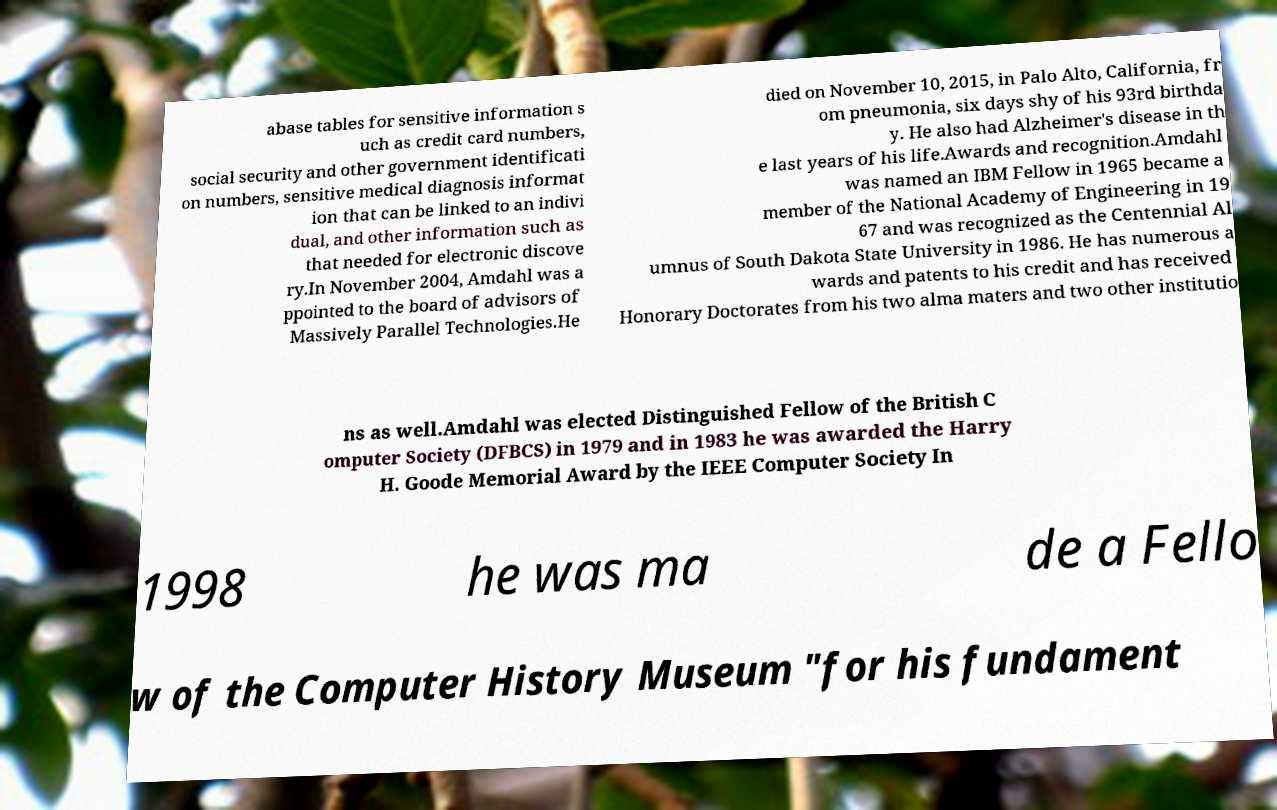Could you assist in decoding the text presented in this image and type it out clearly? abase tables for sensitive information s uch as credit card numbers, social security and other government identificati on numbers, sensitive medical diagnosis informat ion that can be linked to an indivi dual, and other information such as that needed for electronic discove ry.In November 2004, Amdahl was a ppointed to the board of advisors of Massively Parallel Technologies.He died on November 10, 2015, in Palo Alto, California, fr om pneumonia, six days shy of his 93rd birthda y. He also had Alzheimer's disease in th e last years of his life.Awards and recognition.Amdahl was named an IBM Fellow in 1965 became a member of the National Academy of Engineering in 19 67 and was recognized as the Centennial Al umnus of South Dakota State University in 1986. He has numerous a wards and patents to his credit and has received Honorary Doctorates from his two alma maters and two other institutio ns as well.Amdahl was elected Distinguished Fellow of the British C omputer Society (DFBCS) in 1979 and in 1983 he was awarded the Harry H. Goode Memorial Award by the IEEE Computer Society In 1998 he was ma de a Fello w of the Computer History Museum "for his fundament 